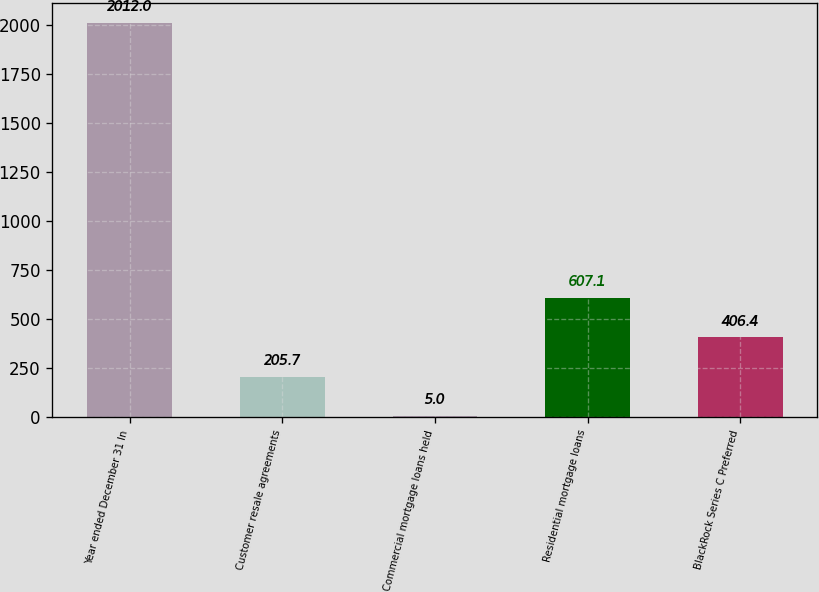<chart> <loc_0><loc_0><loc_500><loc_500><bar_chart><fcel>Year ended December 31 In<fcel>Customer resale agreements<fcel>Commercial mortgage loans held<fcel>Residential mortgage loans<fcel>BlackRock Series C Preferred<nl><fcel>2012<fcel>205.7<fcel>5<fcel>607.1<fcel>406.4<nl></chart> 